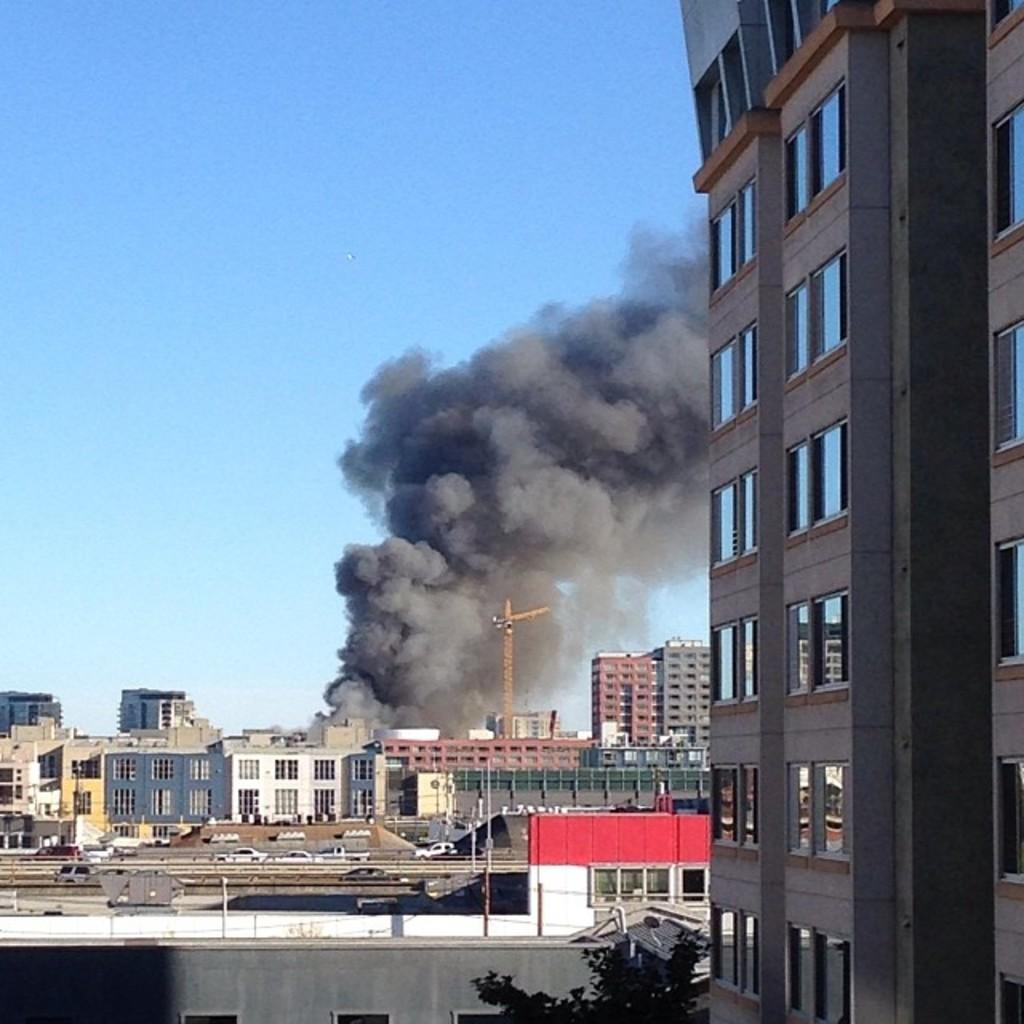What type of structures can be seen in the image? There are buildings in the image. What else is present in the image besides the buildings? There are poles in the image. What can be seen in the foreground area of the image? There is smoke in the foreground area of the image. What is visible in the background of the image? The sky is visible in the background of the image. How many birds are sitting on the buildings in the image? There are no birds present in the image; it only features buildings, poles, smoke, and the sky. 